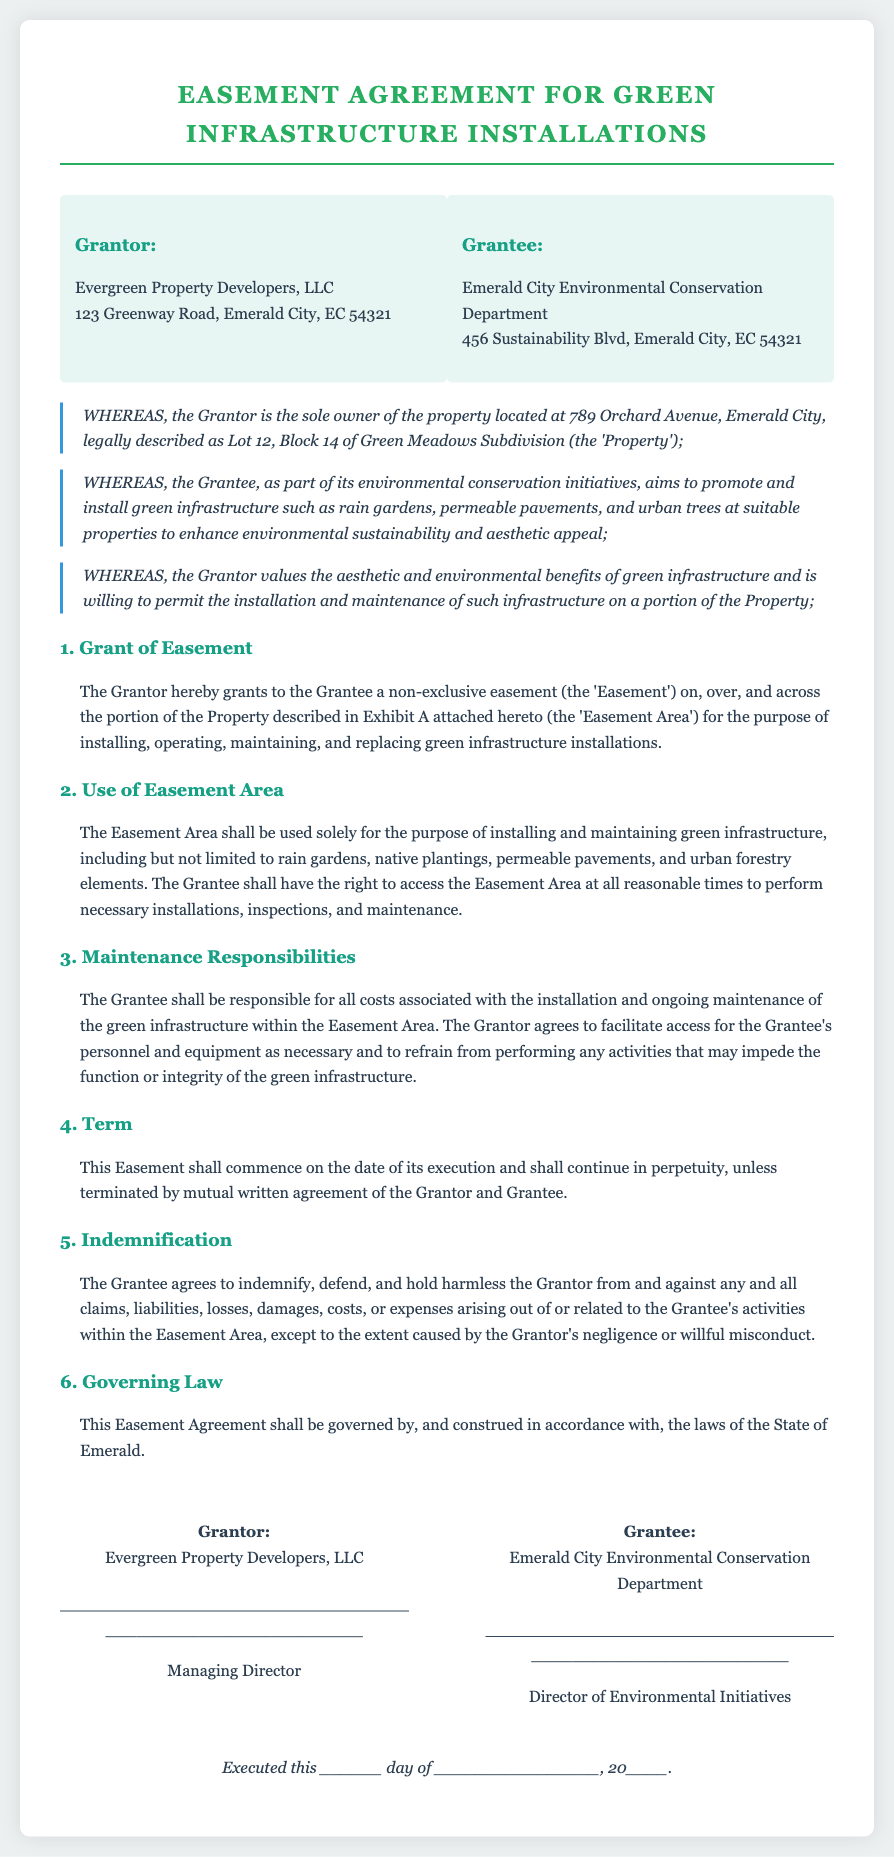What is the name of the Grantor? The Grantor is identified as Evergreen Property Developers, LLC.
Answer: Evergreen Property Developers, LLC What is the address of the Grantee? The address of the Grantee is provided in the document, specifically as 456 Sustainability Blvd, Emerald City, EC 54321.
Answer: 456 Sustainability Blvd, Emerald City, EC 54321 What type of easement is granted? The agreement specifies that the easement is non-exclusive.
Answer: non-exclusive What is the purpose of the Easement Area? The purpose is clearly stated as installing and maintaining green infrastructure.
Answer: installing and maintaining green infrastructure Who is responsible for maintenance costs? The document specifies that the Grantee will be responsible for all costs associated with installation and maintenance.
Answer: Grantee What is the duration of the Easement? The Easement is stated to continue in perpetuity unless terminated by mutual agreement.
Answer: in perpetuity What is the governing law for the Agreement? The document indicates that the Easement Agreement will be governed by the laws of the State of Emerald.
Answer: State of Emerald What installations are mentioned for the Easement Area? Rain gardens, permeable pavements, and urban trees are specified as types of installations.
Answer: rain gardens, permeable pavements, urban trees What is the date format for execution? The execution date format requires a specific day and month as indicated.
Answer: ______ day of ________________, 20____ 